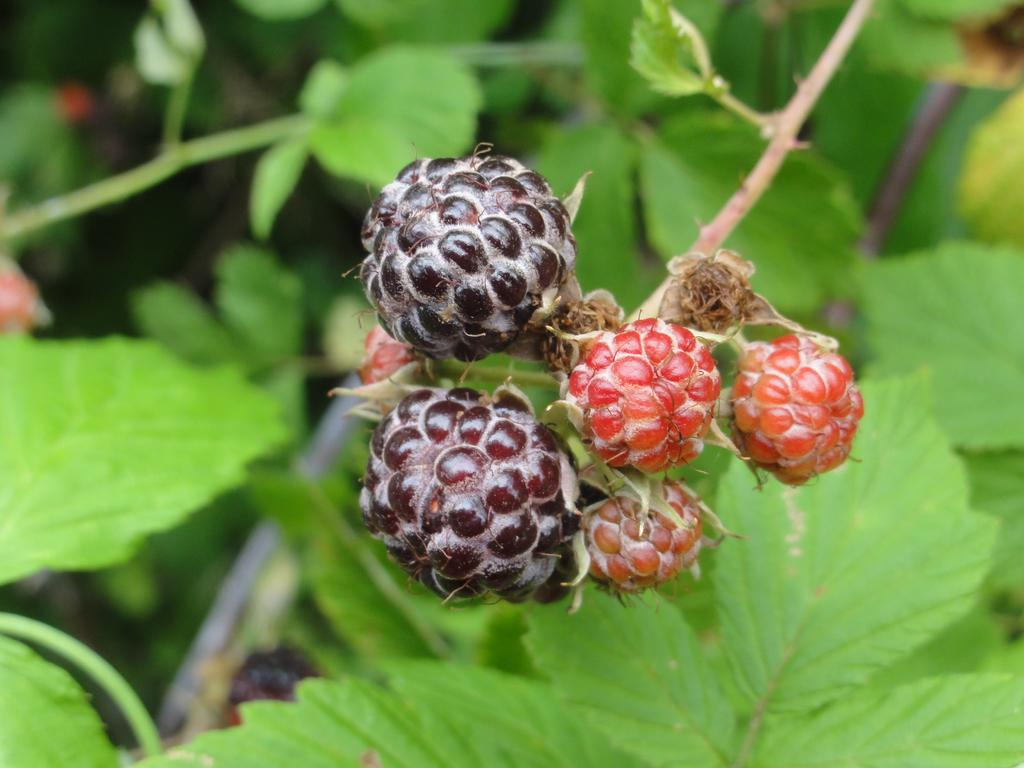What type of food can be seen in the image? There are fruits in the image. What else is present in the image besides the fruits? There are leaves in the image. What type of pancake is being served with the fruits in the image? There is no pancake present in the image; it only features fruits and leaves. What emotion can be seen on the faces of the fruits in the image? Fruits do not have faces or emotions, so this cannot be determined from the image. 